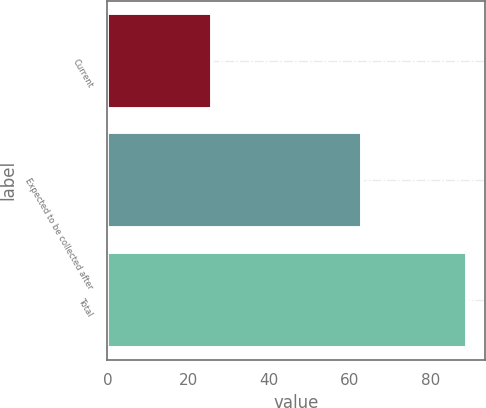<chart> <loc_0><loc_0><loc_500><loc_500><bar_chart><fcel>Current<fcel>Expected to be collected after<fcel>Total<nl><fcel>26<fcel>63<fcel>89<nl></chart> 